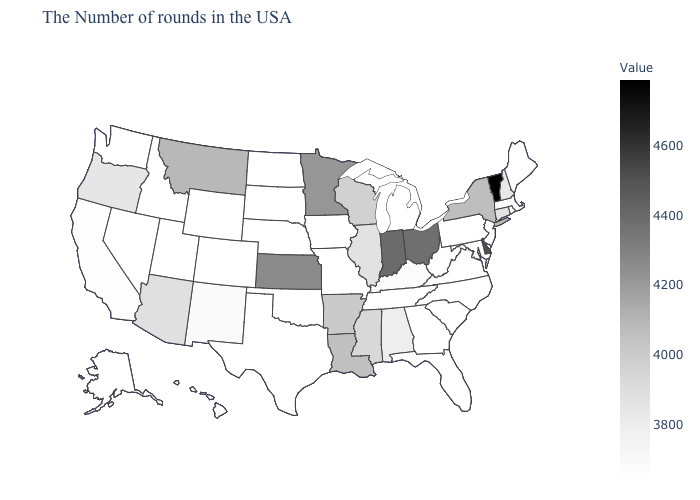Does Idaho have the lowest value in the USA?
Be succinct. Yes. Does the map have missing data?
Short answer required. No. Does New Jersey have a lower value than Illinois?
Short answer required. Yes. Which states have the highest value in the USA?
Answer briefly. Vermont. Does Kentucky have the lowest value in the South?
Be succinct. No. Does the map have missing data?
Concise answer only. No. 